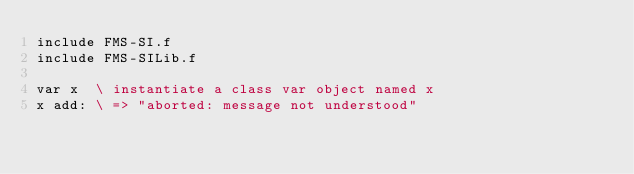<code> <loc_0><loc_0><loc_500><loc_500><_Forth_>include FMS-SI.f
include FMS-SILib.f

var x  \ instantiate a class var object named x
x add: \ => "aborted: message not understood"
</code> 